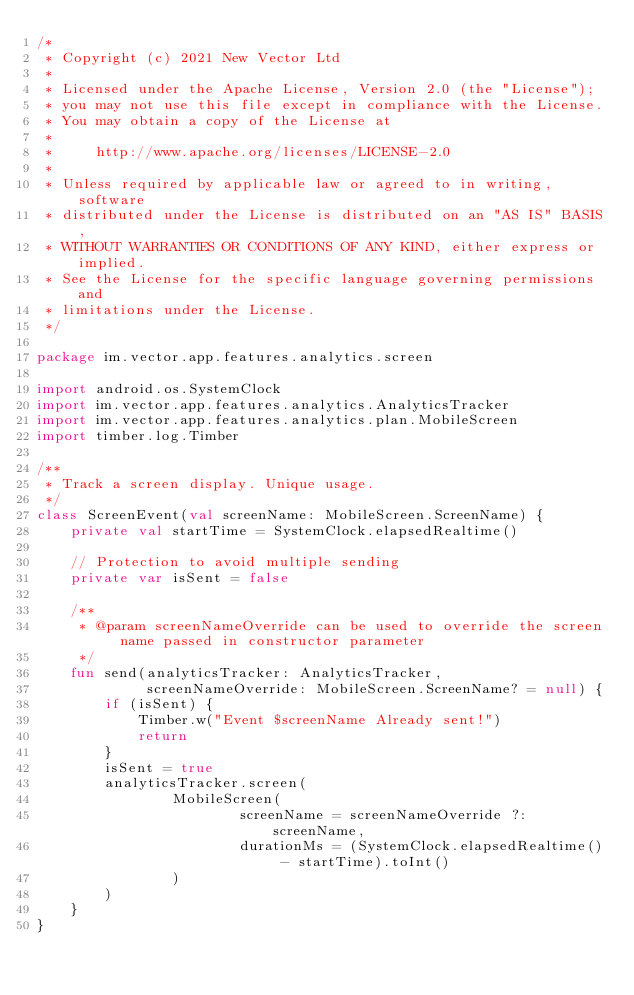Convert code to text. <code><loc_0><loc_0><loc_500><loc_500><_Kotlin_>/*
 * Copyright (c) 2021 New Vector Ltd
 *
 * Licensed under the Apache License, Version 2.0 (the "License");
 * you may not use this file except in compliance with the License.
 * You may obtain a copy of the License at
 *
 *     http://www.apache.org/licenses/LICENSE-2.0
 *
 * Unless required by applicable law or agreed to in writing, software
 * distributed under the License is distributed on an "AS IS" BASIS,
 * WITHOUT WARRANTIES OR CONDITIONS OF ANY KIND, either express or implied.
 * See the License for the specific language governing permissions and
 * limitations under the License.
 */

package im.vector.app.features.analytics.screen

import android.os.SystemClock
import im.vector.app.features.analytics.AnalyticsTracker
import im.vector.app.features.analytics.plan.MobileScreen
import timber.log.Timber

/**
 * Track a screen display. Unique usage.
 */
class ScreenEvent(val screenName: MobileScreen.ScreenName) {
    private val startTime = SystemClock.elapsedRealtime()

    // Protection to avoid multiple sending
    private var isSent = false

    /**
     * @param screenNameOverride can be used to override the screen name passed in constructor parameter
     */
    fun send(analyticsTracker: AnalyticsTracker,
             screenNameOverride: MobileScreen.ScreenName? = null) {
        if (isSent) {
            Timber.w("Event $screenName Already sent!")
            return
        }
        isSent = true
        analyticsTracker.screen(
                MobileScreen(
                        screenName = screenNameOverride ?: screenName,
                        durationMs = (SystemClock.elapsedRealtime() - startTime).toInt()
                )
        )
    }
}
</code> 